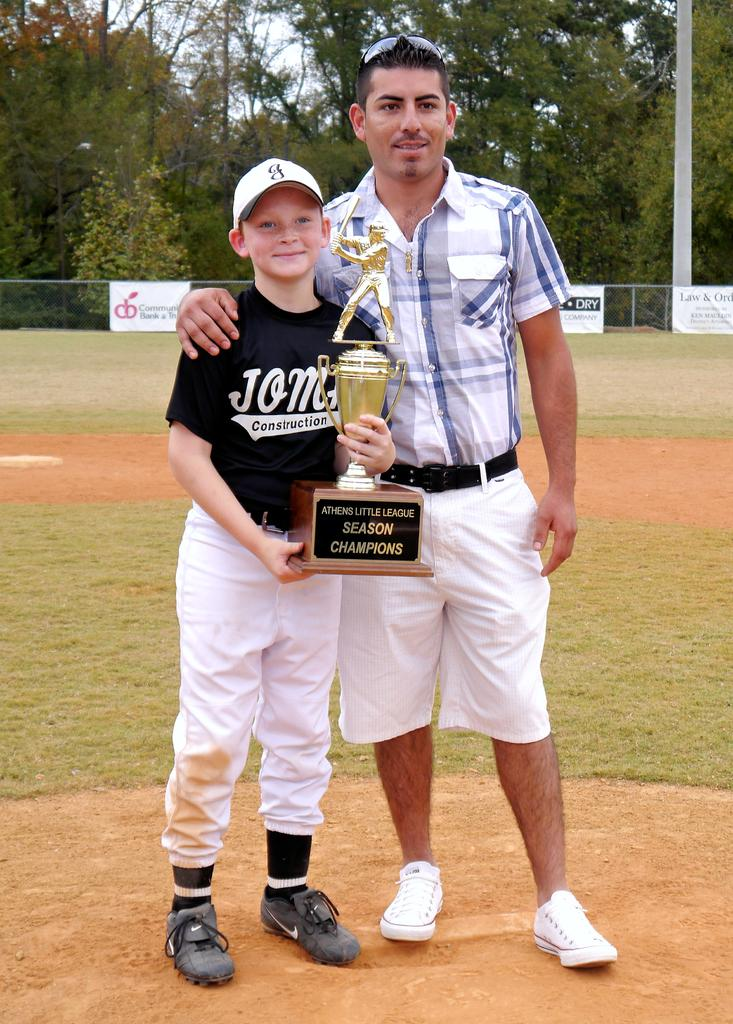<image>
Render a clear and concise summary of the photo. a man and boy holding a Season Champions baseball trophy 